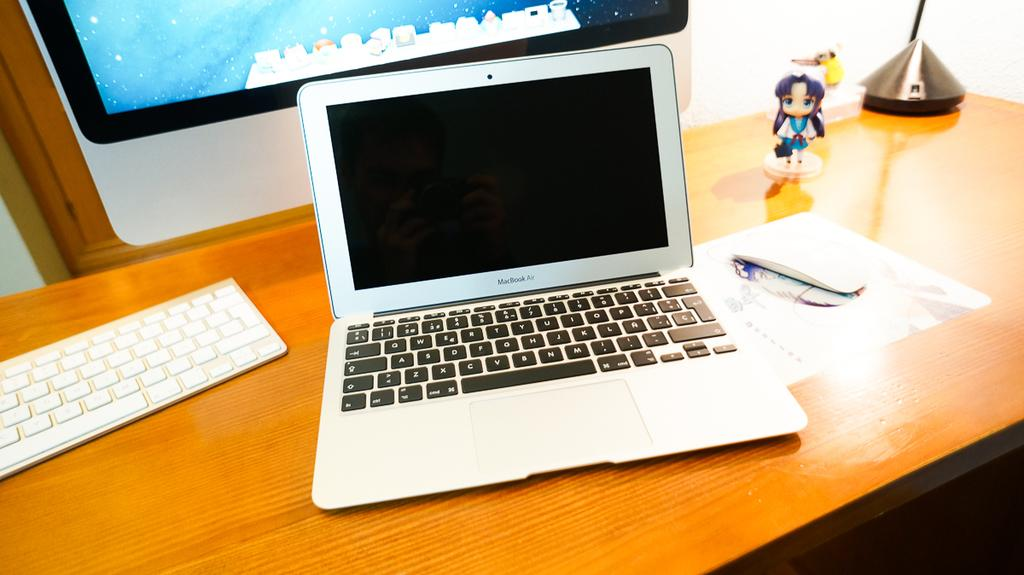Provide a one-sentence caption for the provided image. a MacBook Air computer on a desk in front of a larger monitor. 